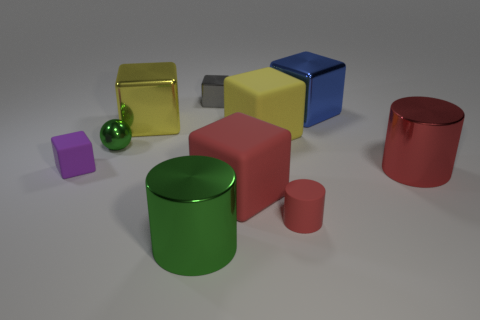The metallic thing that is the same color as the tiny rubber cylinder is what size?
Provide a succinct answer. Large. There is a purple rubber object; what shape is it?
Offer a terse response. Cube. What is the color of the shiny object that is both behind the purple cube and on the right side of the small gray metal thing?
Your response must be concise. Blue. What is the green sphere made of?
Keep it short and to the point. Metal. What shape is the red matte thing on the left side of the small red matte cylinder?
Your answer should be compact. Cube. There is another metallic cube that is the same size as the yellow shiny block; what is its color?
Make the answer very short. Blue. Are the block that is left of the tiny green sphere and the red block made of the same material?
Provide a succinct answer. Yes. There is a block that is in front of the tiny green metallic thing and left of the gray block; what size is it?
Offer a very short reply. Small. There is a red cylinder that is in front of the red shiny cylinder; what size is it?
Your answer should be compact. Small. What is the shape of the big matte object that is the same color as the matte cylinder?
Your answer should be compact. Cube. 